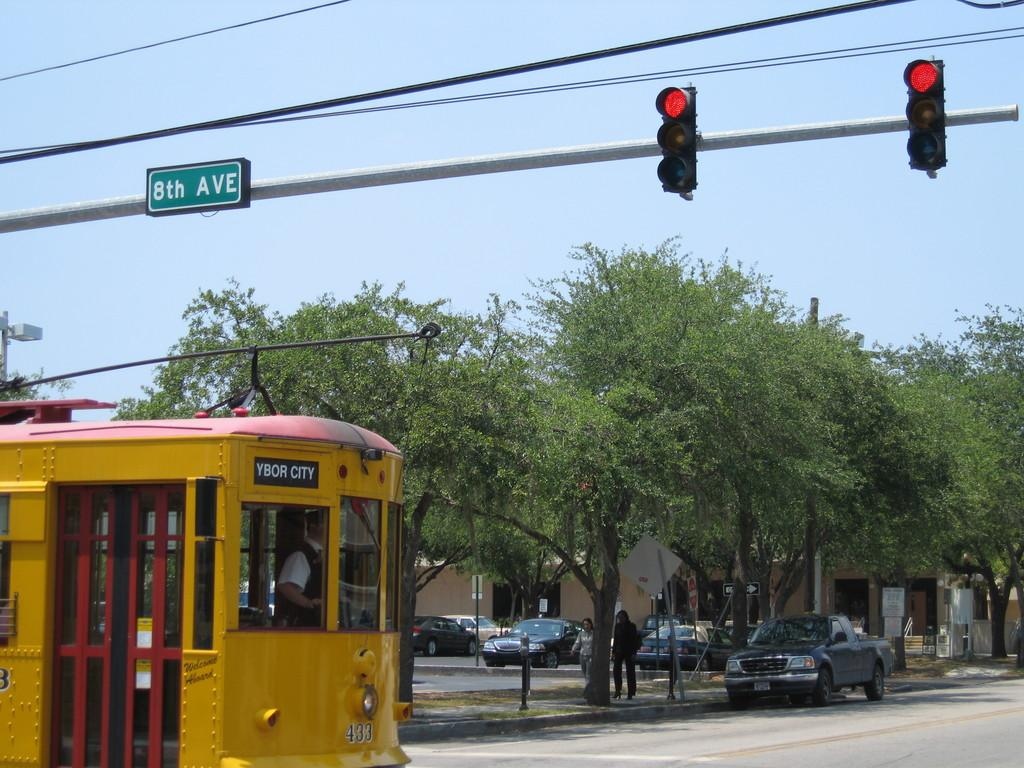<image>
Relay a brief, clear account of the picture shown. The yellow tram shown in the picture is going to Ybor city. 